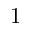Convert formula to latex. <formula><loc_0><loc_0><loc_500><loc_500>1</formula> 